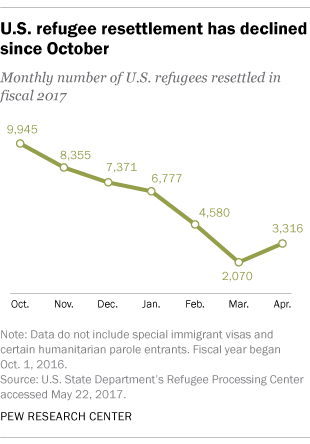Outline some significant characteristics in this image. The value of the monthly number of U.S. refugees in March 2070 is [data]. The median value is not equal to 5032. 